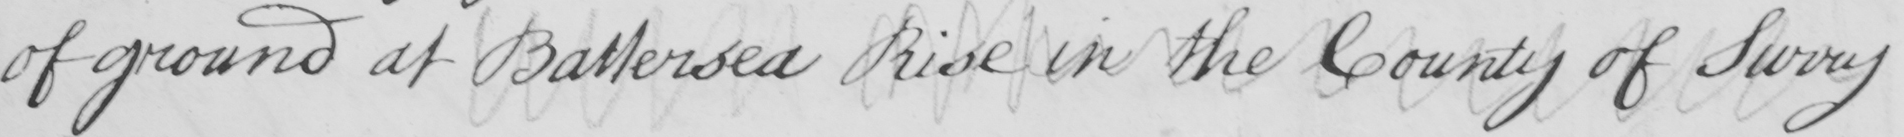What text is written in this handwritten line? of ground at Battersea Rise in the County of Surry 